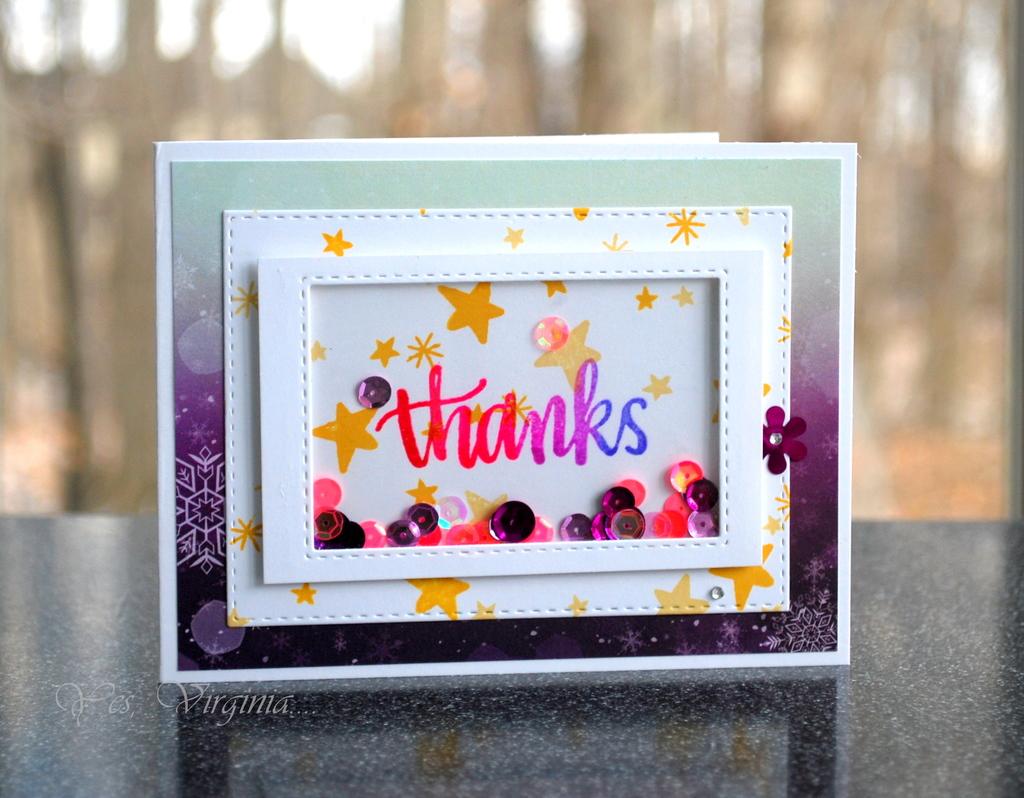What word is shown in the frame?
Your answer should be very brief. Thanks. How many letter words are in the frame?
Your answer should be very brief. 6. 